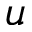Convert formula to latex. <formula><loc_0><loc_0><loc_500><loc_500>u</formula> 